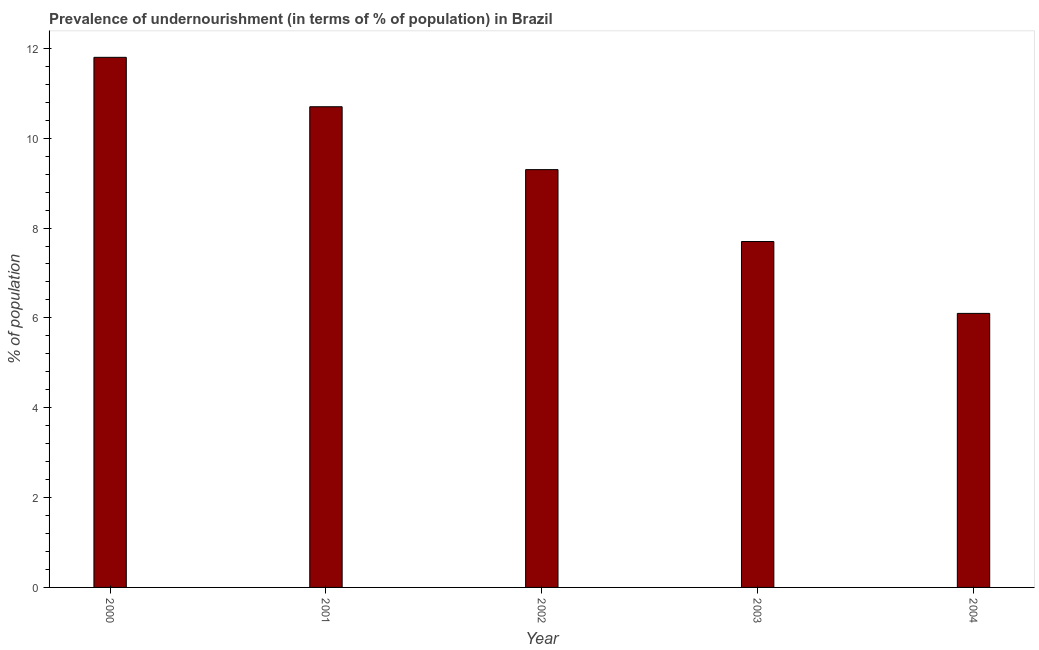Does the graph contain any zero values?
Ensure brevity in your answer.  No. Does the graph contain grids?
Your response must be concise. No. What is the title of the graph?
Give a very brief answer. Prevalence of undernourishment (in terms of % of population) in Brazil. What is the label or title of the Y-axis?
Offer a very short reply. % of population. Across all years, what is the maximum percentage of undernourished population?
Your answer should be very brief. 11.8. Across all years, what is the minimum percentage of undernourished population?
Your response must be concise. 6.1. In which year was the percentage of undernourished population maximum?
Your answer should be compact. 2000. In which year was the percentage of undernourished population minimum?
Your answer should be very brief. 2004. What is the sum of the percentage of undernourished population?
Provide a short and direct response. 45.6. What is the difference between the percentage of undernourished population in 2002 and 2003?
Give a very brief answer. 1.6. What is the average percentage of undernourished population per year?
Provide a short and direct response. 9.12. What is the ratio of the percentage of undernourished population in 2002 to that in 2003?
Ensure brevity in your answer.  1.21. Is the difference between the percentage of undernourished population in 2001 and 2004 greater than the difference between any two years?
Make the answer very short. No. What is the difference between the highest and the second highest percentage of undernourished population?
Keep it short and to the point. 1.1. In how many years, is the percentage of undernourished population greater than the average percentage of undernourished population taken over all years?
Provide a succinct answer. 3. How many bars are there?
Your answer should be very brief. 5. Are all the bars in the graph horizontal?
Ensure brevity in your answer.  No. What is the difference between two consecutive major ticks on the Y-axis?
Offer a terse response. 2. What is the % of population of 2001?
Your response must be concise. 10.7. What is the % of population of 2003?
Your response must be concise. 7.7. What is the % of population of 2004?
Your answer should be compact. 6.1. What is the difference between the % of population in 2000 and 2001?
Your answer should be very brief. 1.1. What is the difference between the % of population in 2000 and 2002?
Your response must be concise. 2.5. What is the difference between the % of population in 2000 and 2004?
Give a very brief answer. 5.7. What is the difference between the % of population in 2001 and 2003?
Provide a short and direct response. 3. What is the difference between the % of population in 2002 and 2003?
Provide a short and direct response. 1.6. What is the difference between the % of population in 2002 and 2004?
Your answer should be compact. 3.2. What is the ratio of the % of population in 2000 to that in 2001?
Offer a terse response. 1.1. What is the ratio of the % of population in 2000 to that in 2002?
Offer a terse response. 1.27. What is the ratio of the % of population in 2000 to that in 2003?
Your answer should be compact. 1.53. What is the ratio of the % of population in 2000 to that in 2004?
Offer a terse response. 1.93. What is the ratio of the % of population in 2001 to that in 2002?
Offer a terse response. 1.15. What is the ratio of the % of population in 2001 to that in 2003?
Provide a succinct answer. 1.39. What is the ratio of the % of population in 2001 to that in 2004?
Offer a terse response. 1.75. What is the ratio of the % of population in 2002 to that in 2003?
Give a very brief answer. 1.21. What is the ratio of the % of population in 2002 to that in 2004?
Provide a short and direct response. 1.52. What is the ratio of the % of population in 2003 to that in 2004?
Keep it short and to the point. 1.26. 